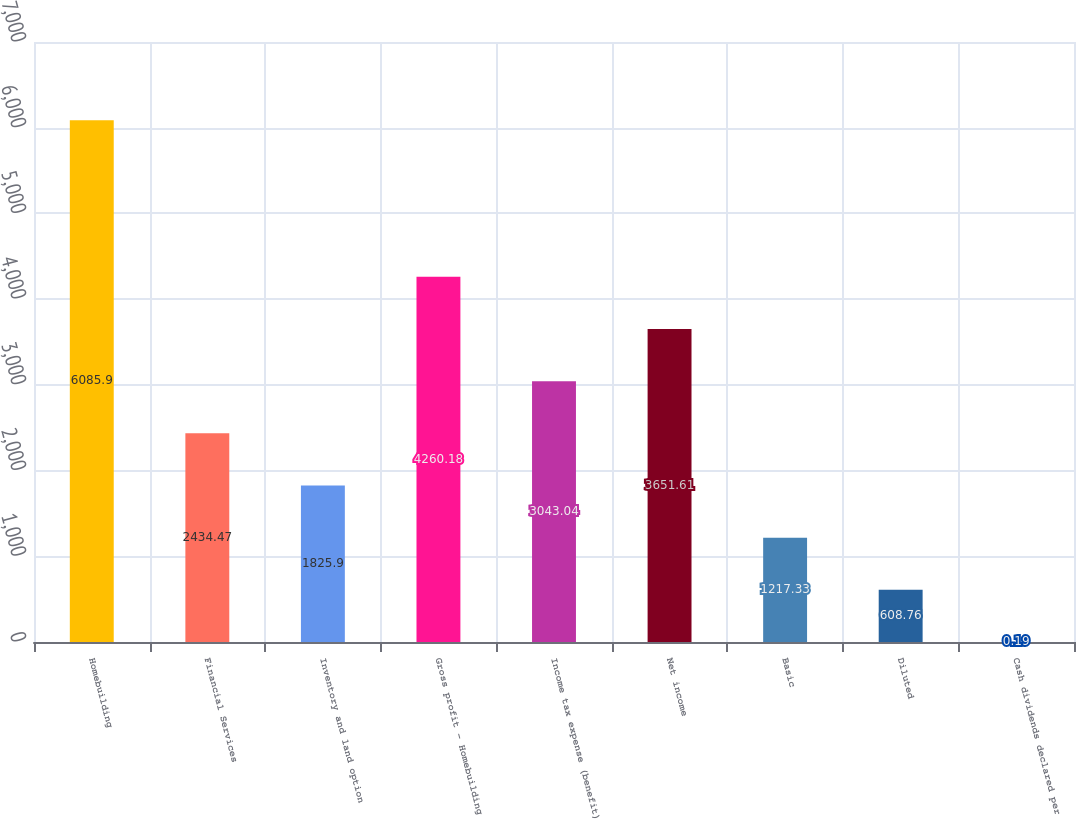<chart> <loc_0><loc_0><loc_500><loc_500><bar_chart><fcel>Homebuilding<fcel>Financial Services<fcel>Inventory and land option<fcel>Gross profit - Homebuilding<fcel>Income tax expense (benefit)<fcel>Net income<fcel>Basic<fcel>Diluted<fcel>Cash dividends declared per<nl><fcel>6085.9<fcel>2434.47<fcel>1825.9<fcel>4260.18<fcel>3043.04<fcel>3651.61<fcel>1217.33<fcel>608.76<fcel>0.19<nl></chart> 